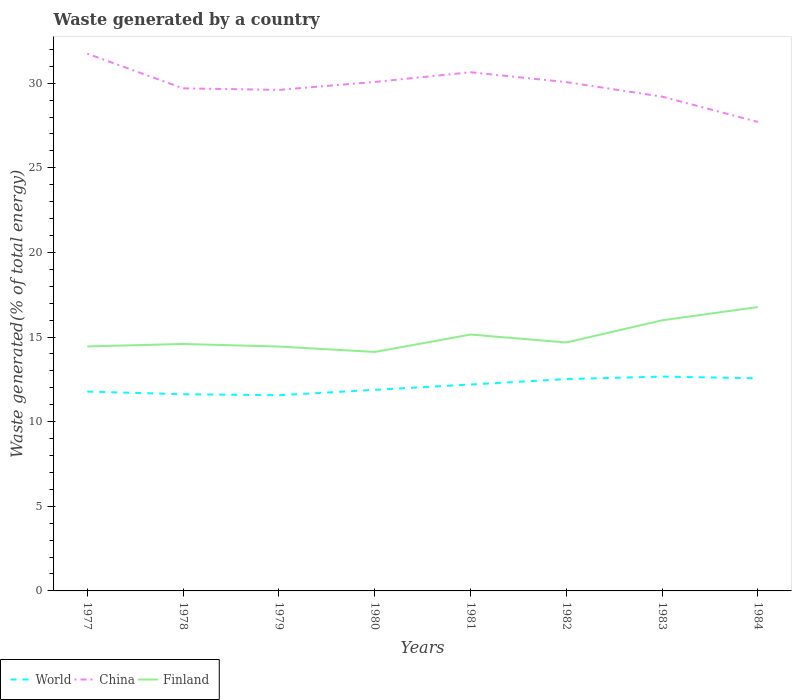Does the line corresponding to World intersect with the line corresponding to China?
Provide a short and direct response. No. Is the number of lines equal to the number of legend labels?
Your answer should be very brief. Yes. Across all years, what is the maximum total waste generated in Finland?
Your response must be concise. 14.12. What is the total total waste generated in World in the graph?
Your answer should be very brief. -0.95. What is the difference between the highest and the second highest total waste generated in China?
Make the answer very short. 4.04. Is the total waste generated in China strictly greater than the total waste generated in World over the years?
Give a very brief answer. No. How many lines are there?
Give a very brief answer. 3. Are the values on the major ticks of Y-axis written in scientific E-notation?
Provide a succinct answer. No. Does the graph contain any zero values?
Give a very brief answer. No. Does the graph contain grids?
Keep it short and to the point. No. Where does the legend appear in the graph?
Offer a very short reply. Bottom left. What is the title of the graph?
Make the answer very short. Waste generated by a country. What is the label or title of the Y-axis?
Your answer should be compact. Waste generated(% of total energy). What is the Waste generated(% of total energy) of World in 1977?
Give a very brief answer. 11.78. What is the Waste generated(% of total energy) in China in 1977?
Make the answer very short. 31.74. What is the Waste generated(% of total energy) of Finland in 1977?
Offer a terse response. 14.45. What is the Waste generated(% of total energy) in World in 1978?
Your answer should be very brief. 11.62. What is the Waste generated(% of total energy) in China in 1978?
Offer a very short reply. 29.7. What is the Waste generated(% of total energy) of Finland in 1978?
Keep it short and to the point. 14.59. What is the Waste generated(% of total energy) in World in 1979?
Provide a succinct answer. 11.56. What is the Waste generated(% of total energy) of China in 1979?
Ensure brevity in your answer.  29.6. What is the Waste generated(% of total energy) of Finland in 1979?
Keep it short and to the point. 14.44. What is the Waste generated(% of total energy) of World in 1980?
Provide a succinct answer. 11.88. What is the Waste generated(% of total energy) in China in 1980?
Ensure brevity in your answer.  30.07. What is the Waste generated(% of total energy) in Finland in 1980?
Offer a very short reply. 14.12. What is the Waste generated(% of total energy) in World in 1981?
Ensure brevity in your answer.  12.2. What is the Waste generated(% of total energy) of China in 1981?
Provide a short and direct response. 30.65. What is the Waste generated(% of total energy) in Finland in 1981?
Keep it short and to the point. 15.15. What is the Waste generated(% of total energy) of World in 1982?
Make the answer very short. 12.52. What is the Waste generated(% of total energy) of China in 1982?
Your response must be concise. 30.06. What is the Waste generated(% of total energy) of Finland in 1982?
Give a very brief answer. 14.68. What is the Waste generated(% of total energy) of World in 1983?
Make the answer very short. 12.66. What is the Waste generated(% of total energy) of China in 1983?
Offer a terse response. 29.2. What is the Waste generated(% of total energy) in Finland in 1983?
Keep it short and to the point. 15.99. What is the Waste generated(% of total energy) in World in 1984?
Offer a very short reply. 12.56. What is the Waste generated(% of total energy) in China in 1984?
Keep it short and to the point. 27.71. What is the Waste generated(% of total energy) of Finland in 1984?
Your answer should be very brief. 16.77. Across all years, what is the maximum Waste generated(% of total energy) in World?
Make the answer very short. 12.66. Across all years, what is the maximum Waste generated(% of total energy) in China?
Ensure brevity in your answer.  31.74. Across all years, what is the maximum Waste generated(% of total energy) of Finland?
Offer a very short reply. 16.77. Across all years, what is the minimum Waste generated(% of total energy) of World?
Provide a succinct answer. 11.56. Across all years, what is the minimum Waste generated(% of total energy) in China?
Provide a succinct answer. 27.71. Across all years, what is the minimum Waste generated(% of total energy) of Finland?
Provide a succinct answer. 14.12. What is the total Waste generated(% of total energy) of World in the graph?
Make the answer very short. 96.78. What is the total Waste generated(% of total energy) in China in the graph?
Make the answer very short. 238.73. What is the total Waste generated(% of total energy) of Finland in the graph?
Your answer should be compact. 120.19. What is the difference between the Waste generated(% of total energy) of World in 1977 and that in 1978?
Provide a succinct answer. 0.16. What is the difference between the Waste generated(% of total energy) in China in 1977 and that in 1978?
Make the answer very short. 2.05. What is the difference between the Waste generated(% of total energy) of Finland in 1977 and that in 1978?
Offer a very short reply. -0.14. What is the difference between the Waste generated(% of total energy) in World in 1977 and that in 1979?
Provide a short and direct response. 0.22. What is the difference between the Waste generated(% of total energy) of China in 1977 and that in 1979?
Keep it short and to the point. 2.14. What is the difference between the Waste generated(% of total energy) of Finland in 1977 and that in 1979?
Keep it short and to the point. 0.01. What is the difference between the Waste generated(% of total energy) of World in 1977 and that in 1980?
Ensure brevity in your answer.  -0.1. What is the difference between the Waste generated(% of total energy) of China in 1977 and that in 1980?
Provide a succinct answer. 1.67. What is the difference between the Waste generated(% of total energy) of Finland in 1977 and that in 1980?
Your answer should be very brief. 0.33. What is the difference between the Waste generated(% of total energy) of World in 1977 and that in 1981?
Ensure brevity in your answer.  -0.42. What is the difference between the Waste generated(% of total energy) of China in 1977 and that in 1981?
Keep it short and to the point. 1.1. What is the difference between the Waste generated(% of total energy) of Finland in 1977 and that in 1981?
Offer a terse response. -0.7. What is the difference between the Waste generated(% of total energy) of World in 1977 and that in 1982?
Offer a very short reply. -0.74. What is the difference between the Waste generated(% of total energy) of China in 1977 and that in 1982?
Ensure brevity in your answer.  1.68. What is the difference between the Waste generated(% of total energy) in Finland in 1977 and that in 1982?
Offer a terse response. -0.23. What is the difference between the Waste generated(% of total energy) in World in 1977 and that in 1983?
Your answer should be compact. -0.89. What is the difference between the Waste generated(% of total energy) of China in 1977 and that in 1983?
Your answer should be very brief. 2.54. What is the difference between the Waste generated(% of total energy) of Finland in 1977 and that in 1983?
Offer a terse response. -1.54. What is the difference between the Waste generated(% of total energy) in World in 1977 and that in 1984?
Provide a succinct answer. -0.78. What is the difference between the Waste generated(% of total energy) in China in 1977 and that in 1984?
Provide a short and direct response. 4.04. What is the difference between the Waste generated(% of total energy) in Finland in 1977 and that in 1984?
Keep it short and to the point. -2.33. What is the difference between the Waste generated(% of total energy) of World in 1978 and that in 1979?
Make the answer very short. 0.06. What is the difference between the Waste generated(% of total energy) in China in 1978 and that in 1979?
Keep it short and to the point. 0.09. What is the difference between the Waste generated(% of total energy) of Finland in 1978 and that in 1979?
Offer a very short reply. 0.15. What is the difference between the Waste generated(% of total energy) in World in 1978 and that in 1980?
Offer a very short reply. -0.26. What is the difference between the Waste generated(% of total energy) of China in 1978 and that in 1980?
Keep it short and to the point. -0.38. What is the difference between the Waste generated(% of total energy) in Finland in 1978 and that in 1980?
Your answer should be compact. 0.47. What is the difference between the Waste generated(% of total energy) in World in 1978 and that in 1981?
Offer a very short reply. -0.57. What is the difference between the Waste generated(% of total energy) of China in 1978 and that in 1981?
Your answer should be very brief. -0.95. What is the difference between the Waste generated(% of total energy) of Finland in 1978 and that in 1981?
Provide a short and direct response. -0.56. What is the difference between the Waste generated(% of total energy) in World in 1978 and that in 1982?
Offer a terse response. -0.89. What is the difference between the Waste generated(% of total energy) of China in 1978 and that in 1982?
Ensure brevity in your answer.  -0.37. What is the difference between the Waste generated(% of total energy) of Finland in 1978 and that in 1982?
Make the answer very short. -0.09. What is the difference between the Waste generated(% of total energy) of World in 1978 and that in 1983?
Give a very brief answer. -1.04. What is the difference between the Waste generated(% of total energy) of China in 1978 and that in 1983?
Provide a short and direct response. 0.49. What is the difference between the Waste generated(% of total energy) in World in 1978 and that in 1984?
Provide a short and direct response. -0.94. What is the difference between the Waste generated(% of total energy) in China in 1978 and that in 1984?
Offer a terse response. 1.99. What is the difference between the Waste generated(% of total energy) in Finland in 1978 and that in 1984?
Provide a short and direct response. -2.18. What is the difference between the Waste generated(% of total energy) in World in 1979 and that in 1980?
Make the answer very short. -0.32. What is the difference between the Waste generated(% of total energy) in China in 1979 and that in 1980?
Give a very brief answer. -0.47. What is the difference between the Waste generated(% of total energy) in Finland in 1979 and that in 1980?
Offer a terse response. 0.32. What is the difference between the Waste generated(% of total energy) of World in 1979 and that in 1981?
Offer a very short reply. -0.63. What is the difference between the Waste generated(% of total energy) in China in 1979 and that in 1981?
Offer a terse response. -1.04. What is the difference between the Waste generated(% of total energy) of Finland in 1979 and that in 1981?
Give a very brief answer. -0.71. What is the difference between the Waste generated(% of total energy) in World in 1979 and that in 1982?
Your answer should be very brief. -0.95. What is the difference between the Waste generated(% of total energy) of China in 1979 and that in 1982?
Provide a short and direct response. -0.46. What is the difference between the Waste generated(% of total energy) in Finland in 1979 and that in 1982?
Provide a short and direct response. -0.24. What is the difference between the Waste generated(% of total energy) in World in 1979 and that in 1983?
Provide a succinct answer. -1.1. What is the difference between the Waste generated(% of total energy) of China in 1979 and that in 1983?
Give a very brief answer. 0.4. What is the difference between the Waste generated(% of total energy) of Finland in 1979 and that in 1983?
Your response must be concise. -1.55. What is the difference between the Waste generated(% of total energy) of World in 1979 and that in 1984?
Keep it short and to the point. -1. What is the difference between the Waste generated(% of total energy) in China in 1979 and that in 1984?
Offer a very short reply. 1.89. What is the difference between the Waste generated(% of total energy) in Finland in 1979 and that in 1984?
Your answer should be compact. -2.33. What is the difference between the Waste generated(% of total energy) in World in 1980 and that in 1981?
Your answer should be very brief. -0.31. What is the difference between the Waste generated(% of total energy) of China in 1980 and that in 1981?
Give a very brief answer. -0.57. What is the difference between the Waste generated(% of total energy) of Finland in 1980 and that in 1981?
Provide a short and direct response. -1.03. What is the difference between the Waste generated(% of total energy) in World in 1980 and that in 1982?
Provide a short and direct response. -0.63. What is the difference between the Waste generated(% of total energy) of China in 1980 and that in 1982?
Make the answer very short. 0.01. What is the difference between the Waste generated(% of total energy) of Finland in 1980 and that in 1982?
Make the answer very short. -0.56. What is the difference between the Waste generated(% of total energy) in World in 1980 and that in 1983?
Ensure brevity in your answer.  -0.78. What is the difference between the Waste generated(% of total energy) of China in 1980 and that in 1983?
Make the answer very short. 0.87. What is the difference between the Waste generated(% of total energy) in Finland in 1980 and that in 1983?
Ensure brevity in your answer.  -1.87. What is the difference between the Waste generated(% of total energy) in World in 1980 and that in 1984?
Offer a terse response. -0.68. What is the difference between the Waste generated(% of total energy) in China in 1980 and that in 1984?
Give a very brief answer. 2.36. What is the difference between the Waste generated(% of total energy) in Finland in 1980 and that in 1984?
Provide a short and direct response. -2.66. What is the difference between the Waste generated(% of total energy) in World in 1981 and that in 1982?
Your answer should be compact. -0.32. What is the difference between the Waste generated(% of total energy) of China in 1981 and that in 1982?
Keep it short and to the point. 0.58. What is the difference between the Waste generated(% of total energy) of Finland in 1981 and that in 1982?
Keep it short and to the point. 0.47. What is the difference between the Waste generated(% of total energy) in World in 1981 and that in 1983?
Your response must be concise. -0.47. What is the difference between the Waste generated(% of total energy) of China in 1981 and that in 1983?
Give a very brief answer. 1.44. What is the difference between the Waste generated(% of total energy) in Finland in 1981 and that in 1983?
Offer a terse response. -0.84. What is the difference between the Waste generated(% of total energy) in World in 1981 and that in 1984?
Your answer should be very brief. -0.37. What is the difference between the Waste generated(% of total energy) of China in 1981 and that in 1984?
Keep it short and to the point. 2.94. What is the difference between the Waste generated(% of total energy) of Finland in 1981 and that in 1984?
Make the answer very short. -1.63. What is the difference between the Waste generated(% of total energy) in World in 1982 and that in 1983?
Your answer should be very brief. -0.15. What is the difference between the Waste generated(% of total energy) of China in 1982 and that in 1983?
Offer a very short reply. 0.86. What is the difference between the Waste generated(% of total energy) in Finland in 1982 and that in 1983?
Keep it short and to the point. -1.31. What is the difference between the Waste generated(% of total energy) in World in 1982 and that in 1984?
Provide a short and direct response. -0.04. What is the difference between the Waste generated(% of total energy) of China in 1982 and that in 1984?
Your answer should be compact. 2.35. What is the difference between the Waste generated(% of total energy) of Finland in 1982 and that in 1984?
Your answer should be compact. -2.09. What is the difference between the Waste generated(% of total energy) in World in 1983 and that in 1984?
Your answer should be compact. 0.1. What is the difference between the Waste generated(% of total energy) in China in 1983 and that in 1984?
Make the answer very short. 1.5. What is the difference between the Waste generated(% of total energy) of Finland in 1983 and that in 1984?
Your answer should be compact. -0.78. What is the difference between the Waste generated(% of total energy) of World in 1977 and the Waste generated(% of total energy) of China in 1978?
Keep it short and to the point. -17.92. What is the difference between the Waste generated(% of total energy) of World in 1977 and the Waste generated(% of total energy) of Finland in 1978?
Offer a very short reply. -2.81. What is the difference between the Waste generated(% of total energy) in China in 1977 and the Waste generated(% of total energy) in Finland in 1978?
Provide a succinct answer. 17.15. What is the difference between the Waste generated(% of total energy) in World in 1977 and the Waste generated(% of total energy) in China in 1979?
Give a very brief answer. -17.82. What is the difference between the Waste generated(% of total energy) in World in 1977 and the Waste generated(% of total energy) in Finland in 1979?
Offer a terse response. -2.66. What is the difference between the Waste generated(% of total energy) of China in 1977 and the Waste generated(% of total energy) of Finland in 1979?
Give a very brief answer. 17.31. What is the difference between the Waste generated(% of total energy) in World in 1977 and the Waste generated(% of total energy) in China in 1980?
Provide a short and direct response. -18.29. What is the difference between the Waste generated(% of total energy) in World in 1977 and the Waste generated(% of total energy) in Finland in 1980?
Provide a succinct answer. -2.34. What is the difference between the Waste generated(% of total energy) of China in 1977 and the Waste generated(% of total energy) of Finland in 1980?
Your response must be concise. 17.63. What is the difference between the Waste generated(% of total energy) of World in 1977 and the Waste generated(% of total energy) of China in 1981?
Keep it short and to the point. -18.87. What is the difference between the Waste generated(% of total energy) of World in 1977 and the Waste generated(% of total energy) of Finland in 1981?
Offer a very short reply. -3.37. What is the difference between the Waste generated(% of total energy) in China in 1977 and the Waste generated(% of total energy) in Finland in 1981?
Provide a succinct answer. 16.6. What is the difference between the Waste generated(% of total energy) of World in 1977 and the Waste generated(% of total energy) of China in 1982?
Keep it short and to the point. -18.28. What is the difference between the Waste generated(% of total energy) of World in 1977 and the Waste generated(% of total energy) of Finland in 1982?
Your answer should be very brief. -2.9. What is the difference between the Waste generated(% of total energy) in China in 1977 and the Waste generated(% of total energy) in Finland in 1982?
Give a very brief answer. 17.07. What is the difference between the Waste generated(% of total energy) in World in 1977 and the Waste generated(% of total energy) in China in 1983?
Provide a succinct answer. -17.43. What is the difference between the Waste generated(% of total energy) of World in 1977 and the Waste generated(% of total energy) of Finland in 1983?
Ensure brevity in your answer.  -4.21. What is the difference between the Waste generated(% of total energy) in China in 1977 and the Waste generated(% of total energy) in Finland in 1983?
Offer a terse response. 15.75. What is the difference between the Waste generated(% of total energy) of World in 1977 and the Waste generated(% of total energy) of China in 1984?
Your answer should be compact. -15.93. What is the difference between the Waste generated(% of total energy) in World in 1977 and the Waste generated(% of total energy) in Finland in 1984?
Your answer should be very brief. -5. What is the difference between the Waste generated(% of total energy) of China in 1977 and the Waste generated(% of total energy) of Finland in 1984?
Give a very brief answer. 14.97. What is the difference between the Waste generated(% of total energy) in World in 1978 and the Waste generated(% of total energy) in China in 1979?
Your response must be concise. -17.98. What is the difference between the Waste generated(% of total energy) in World in 1978 and the Waste generated(% of total energy) in Finland in 1979?
Provide a succinct answer. -2.82. What is the difference between the Waste generated(% of total energy) of China in 1978 and the Waste generated(% of total energy) of Finland in 1979?
Your answer should be very brief. 15.26. What is the difference between the Waste generated(% of total energy) in World in 1978 and the Waste generated(% of total energy) in China in 1980?
Your answer should be compact. -18.45. What is the difference between the Waste generated(% of total energy) in World in 1978 and the Waste generated(% of total energy) in Finland in 1980?
Give a very brief answer. -2.5. What is the difference between the Waste generated(% of total energy) of China in 1978 and the Waste generated(% of total energy) of Finland in 1980?
Keep it short and to the point. 15.58. What is the difference between the Waste generated(% of total energy) in World in 1978 and the Waste generated(% of total energy) in China in 1981?
Make the answer very short. -19.02. What is the difference between the Waste generated(% of total energy) of World in 1978 and the Waste generated(% of total energy) of Finland in 1981?
Offer a very short reply. -3.52. What is the difference between the Waste generated(% of total energy) of China in 1978 and the Waste generated(% of total energy) of Finland in 1981?
Provide a short and direct response. 14.55. What is the difference between the Waste generated(% of total energy) in World in 1978 and the Waste generated(% of total energy) in China in 1982?
Give a very brief answer. -18.44. What is the difference between the Waste generated(% of total energy) in World in 1978 and the Waste generated(% of total energy) in Finland in 1982?
Ensure brevity in your answer.  -3.06. What is the difference between the Waste generated(% of total energy) of China in 1978 and the Waste generated(% of total energy) of Finland in 1982?
Provide a succinct answer. 15.02. What is the difference between the Waste generated(% of total energy) of World in 1978 and the Waste generated(% of total energy) of China in 1983?
Provide a short and direct response. -17.58. What is the difference between the Waste generated(% of total energy) in World in 1978 and the Waste generated(% of total energy) in Finland in 1983?
Offer a terse response. -4.37. What is the difference between the Waste generated(% of total energy) of China in 1978 and the Waste generated(% of total energy) of Finland in 1983?
Your answer should be compact. 13.7. What is the difference between the Waste generated(% of total energy) of World in 1978 and the Waste generated(% of total energy) of China in 1984?
Offer a terse response. -16.09. What is the difference between the Waste generated(% of total energy) in World in 1978 and the Waste generated(% of total energy) in Finland in 1984?
Your answer should be compact. -5.15. What is the difference between the Waste generated(% of total energy) of China in 1978 and the Waste generated(% of total energy) of Finland in 1984?
Offer a very short reply. 12.92. What is the difference between the Waste generated(% of total energy) of World in 1979 and the Waste generated(% of total energy) of China in 1980?
Your response must be concise. -18.51. What is the difference between the Waste generated(% of total energy) in World in 1979 and the Waste generated(% of total energy) in Finland in 1980?
Your response must be concise. -2.56. What is the difference between the Waste generated(% of total energy) of China in 1979 and the Waste generated(% of total energy) of Finland in 1980?
Your response must be concise. 15.48. What is the difference between the Waste generated(% of total energy) in World in 1979 and the Waste generated(% of total energy) in China in 1981?
Your answer should be very brief. -19.08. What is the difference between the Waste generated(% of total energy) in World in 1979 and the Waste generated(% of total energy) in Finland in 1981?
Offer a very short reply. -3.58. What is the difference between the Waste generated(% of total energy) of China in 1979 and the Waste generated(% of total energy) of Finland in 1981?
Keep it short and to the point. 14.46. What is the difference between the Waste generated(% of total energy) in World in 1979 and the Waste generated(% of total energy) in China in 1982?
Your answer should be very brief. -18.5. What is the difference between the Waste generated(% of total energy) of World in 1979 and the Waste generated(% of total energy) of Finland in 1982?
Your answer should be compact. -3.12. What is the difference between the Waste generated(% of total energy) of China in 1979 and the Waste generated(% of total energy) of Finland in 1982?
Provide a short and direct response. 14.92. What is the difference between the Waste generated(% of total energy) in World in 1979 and the Waste generated(% of total energy) in China in 1983?
Provide a succinct answer. -17.64. What is the difference between the Waste generated(% of total energy) in World in 1979 and the Waste generated(% of total energy) in Finland in 1983?
Provide a succinct answer. -4.43. What is the difference between the Waste generated(% of total energy) of China in 1979 and the Waste generated(% of total energy) of Finland in 1983?
Your response must be concise. 13.61. What is the difference between the Waste generated(% of total energy) in World in 1979 and the Waste generated(% of total energy) in China in 1984?
Give a very brief answer. -16.15. What is the difference between the Waste generated(% of total energy) of World in 1979 and the Waste generated(% of total energy) of Finland in 1984?
Make the answer very short. -5.21. What is the difference between the Waste generated(% of total energy) of China in 1979 and the Waste generated(% of total energy) of Finland in 1984?
Provide a succinct answer. 12.83. What is the difference between the Waste generated(% of total energy) in World in 1980 and the Waste generated(% of total energy) in China in 1981?
Make the answer very short. -18.76. What is the difference between the Waste generated(% of total energy) of World in 1980 and the Waste generated(% of total energy) of Finland in 1981?
Provide a short and direct response. -3.27. What is the difference between the Waste generated(% of total energy) of China in 1980 and the Waste generated(% of total energy) of Finland in 1981?
Your answer should be compact. 14.92. What is the difference between the Waste generated(% of total energy) in World in 1980 and the Waste generated(% of total energy) in China in 1982?
Make the answer very short. -18.18. What is the difference between the Waste generated(% of total energy) of World in 1980 and the Waste generated(% of total energy) of Finland in 1982?
Your response must be concise. -2.8. What is the difference between the Waste generated(% of total energy) in China in 1980 and the Waste generated(% of total energy) in Finland in 1982?
Ensure brevity in your answer.  15.39. What is the difference between the Waste generated(% of total energy) of World in 1980 and the Waste generated(% of total energy) of China in 1983?
Make the answer very short. -17.32. What is the difference between the Waste generated(% of total energy) of World in 1980 and the Waste generated(% of total energy) of Finland in 1983?
Offer a very short reply. -4.11. What is the difference between the Waste generated(% of total energy) in China in 1980 and the Waste generated(% of total energy) in Finland in 1983?
Your response must be concise. 14.08. What is the difference between the Waste generated(% of total energy) in World in 1980 and the Waste generated(% of total energy) in China in 1984?
Offer a terse response. -15.83. What is the difference between the Waste generated(% of total energy) of World in 1980 and the Waste generated(% of total energy) of Finland in 1984?
Offer a terse response. -4.89. What is the difference between the Waste generated(% of total energy) in China in 1980 and the Waste generated(% of total energy) in Finland in 1984?
Provide a short and direct response. 13.3. What is the difference between the Waste generated(% of total energy) in World in 1981 and the Waste generated(% of total energy) in China in 1982?
Provide a short and direct response. -17.87. What is the difference between the Waste generated(% of total energy) in World in 1981 and the Waste generated(% of total energy) in Finland in 1982?
Provide a succinct answer. -2.48. What is the difference between the Waste generated(% of total energy) of China in 1981 and the Waste generated(% of total energy) of Finland in 1982?
Offer a terse response. 15.97. What is the difference between the Waste generated(% of total energy) in World in 1981 and the Waste generated(% of total energy) in China in 1983?
Provide a short and direct response. -17.01. What is the difference between the Waste generated(% of total energy) in World in 1981 and the Waste generated(% of total energy) in Finland in 1983?
Offer a terse response. -3.8. What is the difference between the Waste generated(% of total energy) in China in 1981 and the Waste generated(% of total energy) in Finland in 1983?
Give a very brief answer. 14.65. What is the difference between the Waste generated(% of total energy) of World in 1981 and the Waste generated(% of total energy) of China in 1984?
Your answer should be compact. -15.51. What is the difference between the Waste generated(% of total energy) in World in 1981 and the Waste generated(% of total energy) in Finland in 1984?
Provide a short and direct response. -4.58. What is the difference between the Waste generated(% of total energy) in China in 1981 and the Waste generated(% of total energy) in Finland in 1984?
Give a very brief answer. 13.87. What is the difference between the Waste generated(% of total energy) in World in 1982 and the Waste generated(% of total energy) in China in 1983?
Offer a terse response. -16.69. What is the difference between the Waste generated(% of total energy) in World in 1982 and the Waste generated(% of total energy) in Finland in 1983?
Your response must be concise. -3.47. What is the difference between the Waste generated(% of total energy) of China in 1982 and the Waste generated(% of total energy) of Finland in 1983?
Provide a short and direct response. 14.07. What is the difference between the Waste generated(% of total energy) of World in 1982 and the Waste generated(% of total energy) of China in 1984?
Give a very brief answer. -15.19. What is the difference between the Waste generated(% of total energy) of World in 1982 and the Waste generated(% of total energy) of Finland in 1984?
Give a very brief answer. -4.26. What is the difference between the Waste generated(% of total energy) in China in 1982 and the Waste generated(% of total energy) in Finland in 1984?
Keep it short and to the point. 13.29. What is the difference between the Waste generated(% of total energy) of World in 1983 and the Waste generated(% of total energy) of China in 1984?
Offer a very short reply. -15.04. What is the difference between the Waste generated(% of total energy) in World in 1983 and the Waste generated(% of total energy) in Finland in 1984?
Make the answer very short. -4.11. What is the difference between the Waste generated(% of total energy) in China in 1983 and the Waste generated(% of total energy) in Finland in 1984?
Your answer should be compact. 12.43. What is the average Waste generated(% of total energy) in World per year?
Ensure brevity in your answer.  12.1. What is the average Waste generated(% of total energy) of China per year?
Offer a terse response. 29.84. What is the average Waste generated(% of total energy) of Finland per year?
Your answer should be very brief. 15.02. In the year 1977, what is the difference between the Waste generated(% of total energy) of World and Waste generated(% of total energy) of China?
Offer a very short reply. -19.97. In the year 1977, what is the difference between the Waste generated(% of total energy) in World and Waste generated(% of total energy) in Finland?
Your response must be concise. -2.67. In the year 1977, what is the difference between the Waste generated(% of total energy) in China and Waste generated(% of total energy) in Finland?
Provide a short and direct response. 17.3. In the year 1978, what is the difference between the Waste generated(% of total energy) of World and Waste generated(% of total energy) of China?
Provide a succinct answer. -18.07. In the year 1978, what is the difference between the Waste generated(% of total energy) of World and Waste generated(% of total energy) of Finland?
Make the answer very short. -2.97. In the year 1978, what is the difference between the Waste generated(% of total energy) of China and Waste generated(% of total energy) of Finland?
Give a very brief answer. 15.1. In the year 1979, what is the difference between the Waste generated(% of total energy) of World and Waste generated(% of total energy) of China?
Offer a terse response. -18.04. In the year 1979, what is the difference between the Waste generated(% of total energy) of World and Waste generated(% of total energy) of Finland?
Your response must be concise. -2.88. In the year 1979, what is the difference between the Waste generated(% of total energy) of China and Waste generated(% of total energy) of Finland?
Give a very brief answer. 15.16. In the year 1980, what is the difference between the Waste generated(% of total energy) in World and Waste generated(% of total energy) in China?
Provide a short and direct response. -18.19. In the year 1980, what is the difference between the Waste generated(% of total energy) in World and Waste generated(% of total energy) in Finland?
Ensure brevity in your answer.  -2.24. In the year 1980, what is the difference between the Waste generated(% of total energy) in China and Waste generated(% of total energy) in Finland?
Offer a terse response. 15.95. In the year 1981, what is the difference between the Waste generated(% of total energy) in World and Waste generated(% of total energy) in China?
Offer a very short reply. -18.45. In the year 1981, what is the difference between the Waste generated(% of total energy) in World and Waste generated(% of total energy) in Finland?
Make the answer very short. -2.95. In the year 1981, what is the difference between the Waste generated(% of total energy) in China and Waste generated(% of total energy) in Finland?
Your answer should be compact. 15.5. In the year 1982, what is the difference between the Waste generated(% of total energy) in World and Waste generated(% of total energy) in China?
Offer a terse response. -17.55. In the year 1982, what is the difference between the Waste generated(% of total energy) in World and Waste generated(% of total energy) in Finland?
Offer a very short reply. -2.16. In the year 1982, what is the difference between the Waste generated(% of total energy) of China and Waste generated(% of total energy) of Finland?
Provide a short and direct response. 15.38. In the year 1983, what is the difference between the Waste generated(% of total energy) in World and Waste generated(% of total energy) in China?
Offer a terse response. -16.54. In the year 1983, what is the difference between the Waste generated(% of total energy) of World and Waste generated(% of total energy) of Finland?
Your answer should be compact. -3.33. In the year 1983, what is the difference between the Waste generated(% of total energy) in China and Waste generated(% of total energy) in Finland?
Ensure brevity in your answer.  13.21. In the year 1984, what is the difference between the Waste generated(% of total energy) of World and Waste generated(% of total energy) of China?
Offer a very short reply. -15.15. In the year 1984, what is the difference between the Waste generated(% of total energy) in World and Waste generated(% of total energy) in Finland?
Ensure brevity in your answer.  -4.21. In the year 1984, what is the difference between the Waste generated(% of total energy) in China and Waste generated(% of total energy) in Finland?
Your response must be concise. 10.94. What is the ratio of the Waste generated(% of total energy) of World in 1977 to that in 1978?
Your answer should be compact. 1.01. What is the ratio of the Waste generated(% of total energy) of China in 1977 to that in 1978?
Provide a succinct answer. 1.07. What is the ratio of the Waste generated(% of total energy) in Finland in 1977 to that in 1978?
Your answer should be very brief. 0.99. What is the ratio of the Waste generated(% of total energy) of World in 1977 to that in 1979?
Give a very brief answer. 1.02. What is the ratio of the Waste generated(% of total energy) of China in 1977 to that in 1979?
Give a very brief answer. 1.07. What is the ratio of the Waste generated(% of total energy) of Finland in 1977 to that in 1979?
Offer a terse response. 1. What is the ratio of the Waste generated(% of total energy) in World in 1977 to that in 1980?
Your answer should be compact. 0.99. What is the ratio of the Waste generated(% of total energy) in China in 1977 to that in 1980?
Your answer should be very brief. 1.06. What is the ratio of the Waste generated(% of total energy) in Finland in 1977 to that in 1980?
Your answer should be very brief. 1.02. What is the ratio of the Waste generated(% of total energy) of World in 1977 to that in 1981?
Give a very brief answer. 0.97. What is the ratio of the Waste generated(% of total energy) of China in 1977 to that in 1981?
Provide a succinct answer. 1.04. What is the ratio of the Waste generated(% of total energy) in Finland in 1977 to that in 1981?
Your answer should be compact. 0.95. What is the ratio of the Waste generated(% of total energy) in World in 1977 to that in 1982?
Ensure brevity in your answer.  0.94. What is the ratio of the Waste generated(% of total energy) in China in 1977 to that in 1982?
Provide a succinct answer. 1.06. What is the ratio of the Waste generated(% of total energy) in Finland in 1977 to that in 1982?
Make the answer very short. 0.98. What is the ratio of the Waste generated(% of total energy) of World in 1977 to that in 1983?
Offer a terse response. 0.93. What is the ratio of the Waste generated(% of total energy) in China in 1977 to that in 1983?
Your answer should be compact. 1.09. What is the ratio of the Waste generated(% of total energy) in Finland in 1977 to that in 1983?
Provide a short and direct response. 0.9. What is the ratio of the Waste generated(% of total energy) in World in 1977 to that in 1984?
Ensure brevity in your answer.  0.94. What is the ratio of the Waste generated(% of total energy) of China in 1977 to that in 1984?
Offer a terse response. 1.15. What is the ratio of the Waste generated(% of total energy) in Finland in 1977 to that in 1984?
Your answer should be very brief. 0.86. What is the ratio of the Waste generated(% of total energy) of World in 1978 to that in 1979?
Your answer should be compact. 1.01. What is the ratio of the Waste generated(% of total energy) in Finland in 1978 to that in 1979?
Your answer should be compact. 1.01. What is the ratio of the Waste generated(% of total energy) in World in 1978 to that in 1980?
Provide a succinct answer. 0.98. What is the ratio of the Waste generated(% of total energy) of China in 1978 to that in 1980?
Keep it short and to the point. 0.99. What is the ratio of the Waste generated(% of total energy) of Finland in 1978 to that in 1980?
Give a very brief answer. 1.03. What is the ratio of the Waste generated(% of total energy) in World in 1978 to that in 1981?
Provide a short and direct response. 0.95. What is the ratio of the Waste generated(% of total energy) in China in 1978 to that in 1981?
Offer a very short reply. 0.97. What is the ratio of the Waste generated(% of total energy) of Finland in 1978 to that in 1981?
Give a very brief answer. 0.96. What is the ratio of the Waste generated(% of total energy) in World in 1978 to that in 1982?
Give a very brief answer. 0.93. What is the ratio of the Waste generated(% of total energy) in China in 1978 to that in 1982?
Offer a very short reply. 0.99. What is the ratio of the Waste generated(% of total energy) of Finland in 1978 to that in 1982?
Ensure brevity in your answer.  0.99. What is the ratio of the Waste generated(% of total energy) in World in 1978 to that in 1983?
Offer a very short reply. 0.92. What is the ratio of the Waste generated(% of total energy) of China in 1978 to that in 1983?
Ensure brevity in your answer.  1.02. What is the ratio of the Waste generated(% of total energy) in Finland in 1978 to that in 1983?
Ensure brevity in your answer.  0.91. What is the ratio of the Waste generated(% of total energy) of World in 1978 to that in 1984?
Your response must be concise. 0.93. What is the ratio of the Waste generated(% of total energy) of China in 1978 to that in 1984?
Offer a very short reply. 1.07. What is the ratio of the Waste generated(% of total energy) in Finland in 1978 to that in 1984?
Your answer should be very brief. 0.87. What is the ratio of the Waste generated(% of total energy) in World in 1979 to that in 1980?
Ensure brevity in your answer.  0.97. What is the ratio of the Waste generated(% of total energy) of China in 1979 to that in 1980?
Offer a very short reply. 0.98. What is the ratio of the Waste generated(% of total energy) of Finland in 1979 to that in 1980?
Keep it short and to the point. 1.02. What is the ratio of the Waste generated(% of total energy) in World in 1979 to that in 1981?
Keep it short and to the point. 0.95. What is the ratio of the Waste generated(% of total energy) in China in 1979 to that in 1981?
Provide a short and direct response. 0.97. What is the ratio of the Waste generated(% of total energy) in Finland in 1979 to that in 1981?
Ensure brevity in your answer.  0.95. What is the ratio of the Waste generated(% of total energy) of World in 1979 to that in 1982?
Your response must be concise. 0.92. What is the ratio of the Waste generated(% of total energy) of China in 1979 to that in 1982?
Make the answer very short. 0.98. What is the ratio of the Waste generated(% of total energy) of Finland in 1979 to that in 1982?
Your answer should be very brief. 0.98. What is the ratio of the Waste generated(% of total energy) of World in 1979 to that in 1983?
Make the answer very short. 0.91. What is the ratio of the Waste generated(% of total energy) in China in 1979 to that in 1983?
Offer a very short reply. 1.01. What is the ratio of the Waste generated(% of total energy) in Finland in 1979 to that in 1983?
Your answer should be compact. 0.9. What is the ratio of the Waste generated(% of total energy) of World in 1979 to that in 1984?
Your answer should be compact. 0.92. What is the ratio of the Waste generated(% of total energy) in China in 1979 to that in 1984?
Offer a very short reply. 1.07. What is the ratio of the Waste generated(% of total energy) in Finland in 1979 to that in 1984?
Ensure brevity in your answer.  0.86. What is the ratio of the Waste generated(% of total energy) of World in 1980 to that in 1981?
Offer a terse response. 0.97. What is the ratio of the Waste generated(% of total energy) of China in 1980 to that in 1981?
Offer a terse response. 0.98. What is the ratio of the Waste generated(% of total energy) in Finland in 1980 to that in 1981?
Keep it short and to the point. 0.93. What is the ratio of the Waste generated(% of total energy) of World in 1980 to that in 1982?
Offer a terse response. 0.95. What is the ratio of the Waste generated(% of total energy) in China in 1980 to that in 1982?
Keep it short and to the point. 1. What is the ratio of the Waste generated(% of total energy) in Finland in 1980 to that in 1982?
Provide a succinct answer. 0.96. What is the ratio of the Waste generated(% of total energy) in World in 1980 to that in 1983?
Your response must be concise. 0.94. What is the ratio of the Waste generated(% of total energy) in China in 1980 to that in 1983?
Ensure brevity in your answer.  1.03. What is the ratio of the Waste generated(% of total energy) of Finland in 1980 to that in 1983?
Offer a terse response. 0.88. What is the ratio of the Waste generated(% of total energy) of World in 1980 to that in 1984?
Provide a short and direct response. 0.95. What is the ratio of the Waste generated(% of total energy) in China in 1980 to that in 1984?
Your answer should be very brief. 1.09. What is the ratio of the Waste generated(% of total energy) in Finland in 1980 to that in 1984?
Offer a very short reply. 0.84. What is the ratio of the Waste generated(% of total energy) of World in 1981 to that in 1982?
Your response must be concise. 0.97. What is the ratio of the Waste generated(% of total energy) in China in 1981 to that in 1982?
Provide a short and direct response. 1.02. What is the ratio of the Waste generated(% of total energy) in Finland in 1981 to that in 1982?
Your answer should be compact. 1.03. What is the ratio of the Waste generated(% of total energy) of China in 1981 to that in 1983?
Provide a short and direct response. 1.05. What is the ratio of the Waste generated(% of total energy) of Finland in 1981 to that in 1983?
Provide a short and direct response. 0.95. What is the ratio of the Waste generated(% of total energy) of World in 1981 to that in 1984?
Offer a terse response. 0.97. What is the ratio of the Waste generated(% of total energy) of China in 1981 to that in 1984?
Make the answer very short. 1.11. What is the ratio of the Waste generated(% of total energy) in Finland in 1981 to that in 1984?
Your response must be concise. 0.9. What is the ratio of the Waste generated(% of total energy) of World in 1982 to that in 1983?
Provide a succinct answer. 0.99. What is the ratio of the Waste generated(% of total energy) of China in 1982 to that in 1983?
Offer a terse response. 1.03. What is the ratio of the Waste generated(% of total energy) in Finland in 1982 to that in 1983?
Offer a very short reply. 0.92. What is the ratio of the Waste generated(% of total energy) in China in 1982 to that in 1984?
Your answer should be very brief. 1.08. What is the ratio of the Waste generated(% of total energy) of Finland in 1982 to that in 1984?
Give a very brief answer. 0.88. What is the ratio of the Waste generated(% of total energy) of World in 1983 to that in 1984?
Give a very brief answer. 1.01. What is the ratio of the Waste generated(% of total energy) of China in 1983 to that in 1984?
Give a very brief answer. 1.05. What is the ratio of the Waste generated(% of total energy) in Finland in 1983 to that in 1984?
Give a very brief answer. 0.95. What is the difference between the highest and the second highest Waste generated(% of total energy) of World?
Ensure brevity in your answer.  0.1. What is the difference between the highest and the second highest Waste generated(% of total energy) in China?
Provide a succinct answer. 1.1. What is the difference between the highest and the second highest Waste generated(% of total energy) in Finland?
Provide a succinct answer. 0.78. What is the difference between the highest and the lowest Waste generated(% of total energy) of World?
Ensure brevity in your answer.  1.1. What is the difference between the highest and the lowest Waste generated(% of total energy) of China?
Ensure brevity in your answer.  4.04. What is the difference between the highest and the lowest Waste generated(% of total energy) in Finland?
Offer a terse response. 2.66. 